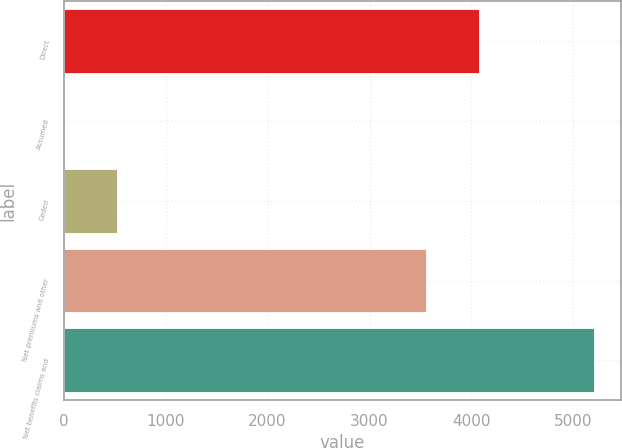<chart> <loc_0><loc_0><loc_500><loc_500><bar_chart><fcel>Direct<fcel>Assumed<fcel>Ceded<fcel>Net premiums and other<fcel>Net benefits claims and<nl><fcel>4075.58<fcel>3.5<fcel>523.58<fcel>3555.5<fcel>5204.3<nl></chart> 